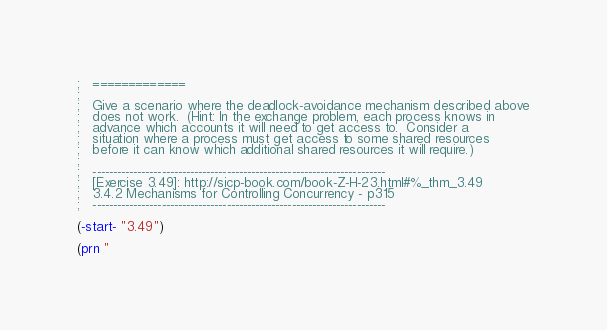<code> <loc_0><loc_0><loc_500><loc_500><_Scheme_>;   =============
;   
;   Give a scenario where the deadlock-avoidance mechanism described above
;   does not work.  (Hint: In the exchange problem, each process knows in
;   advance which accounts it will need to get access to.  Consider a
;   situation where a process must get access to some shared resources
;   before it can know which additional shared resources it will require.)
;   
;   ------------------------------------------------------------------------
;   [Exercise 3.49]: http://sicp-book.com/book-Z-H-23.html#%_thm_3.49
;   3.4.2 Mechanisms for Controlling Concurrency - p315
;   ------------------------------------------------------------------------

(-start- "3.49")

(prn "</code> 